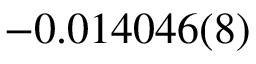<formula> <loc_0><loc_0><loc_500><loc_500>- 0 . 0 1 4 0 4 6 ( 8 )</formula> 